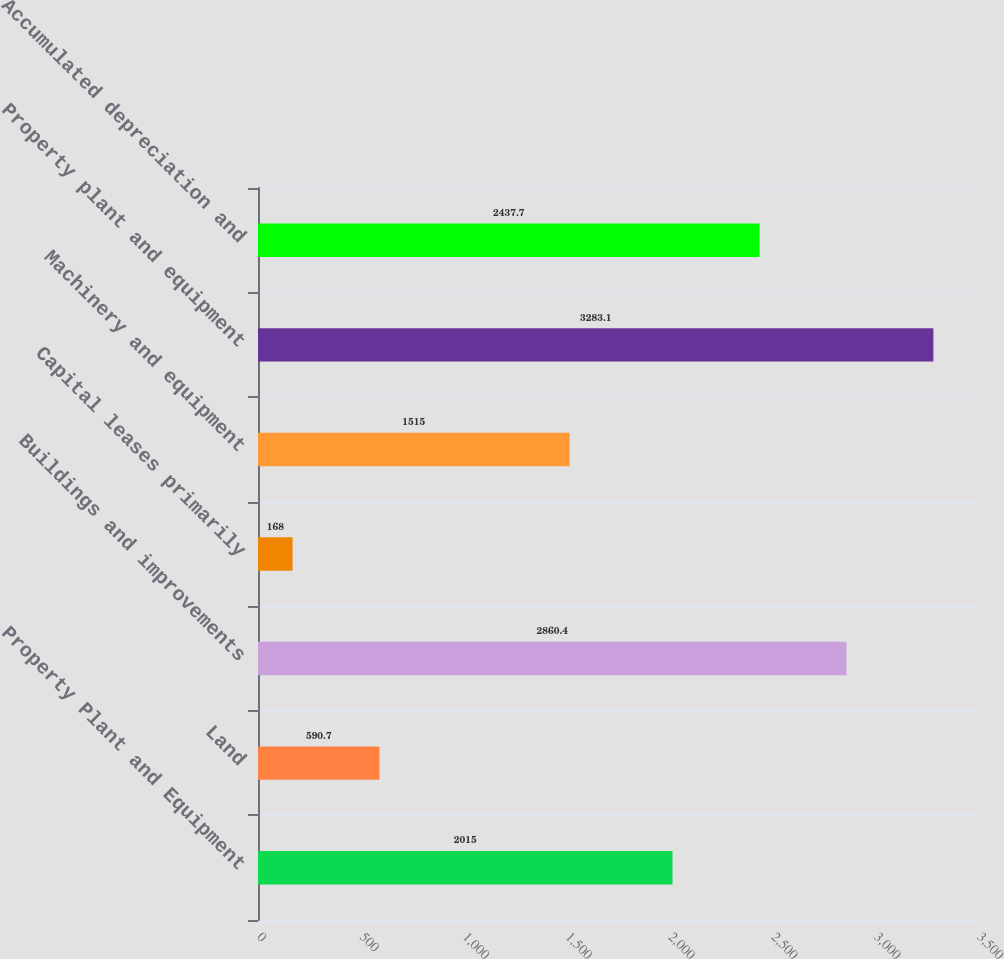Convert chart. <chart><loc_0><loc_0><loc_500><loc_500><bar_chart><fcel>Property Plant and Equipment<fcel>Land<fcel>Buildings and improvements<fcel>Capital leases primarily<fcel>Machinery and equipment<fcel>Property plant and equipment<fcel>Accumulated depreciation and<nl><fcel>2015<fcel>590.7<fcel>2860.4<fcel>168<fcel>1515<fcel>3283.1<fcel>2437.7<nl></chart> 